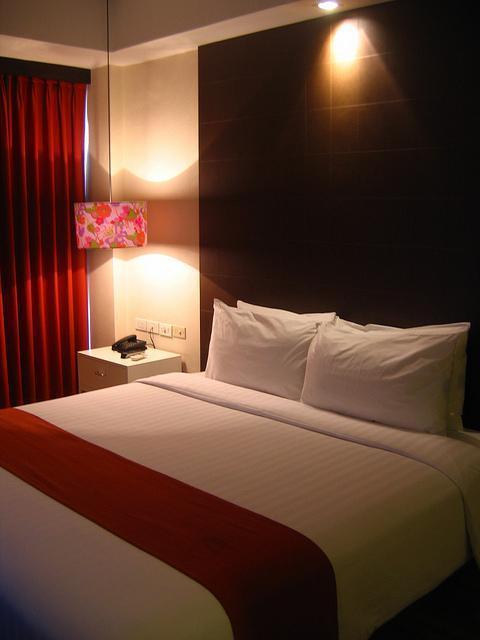How many pillows are on the bed?
Give a very brief answer. 4. 